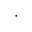Convert formula to latex. <formula><loc_0><loc_0><loc_500><loc_500>\cdot</formula> 